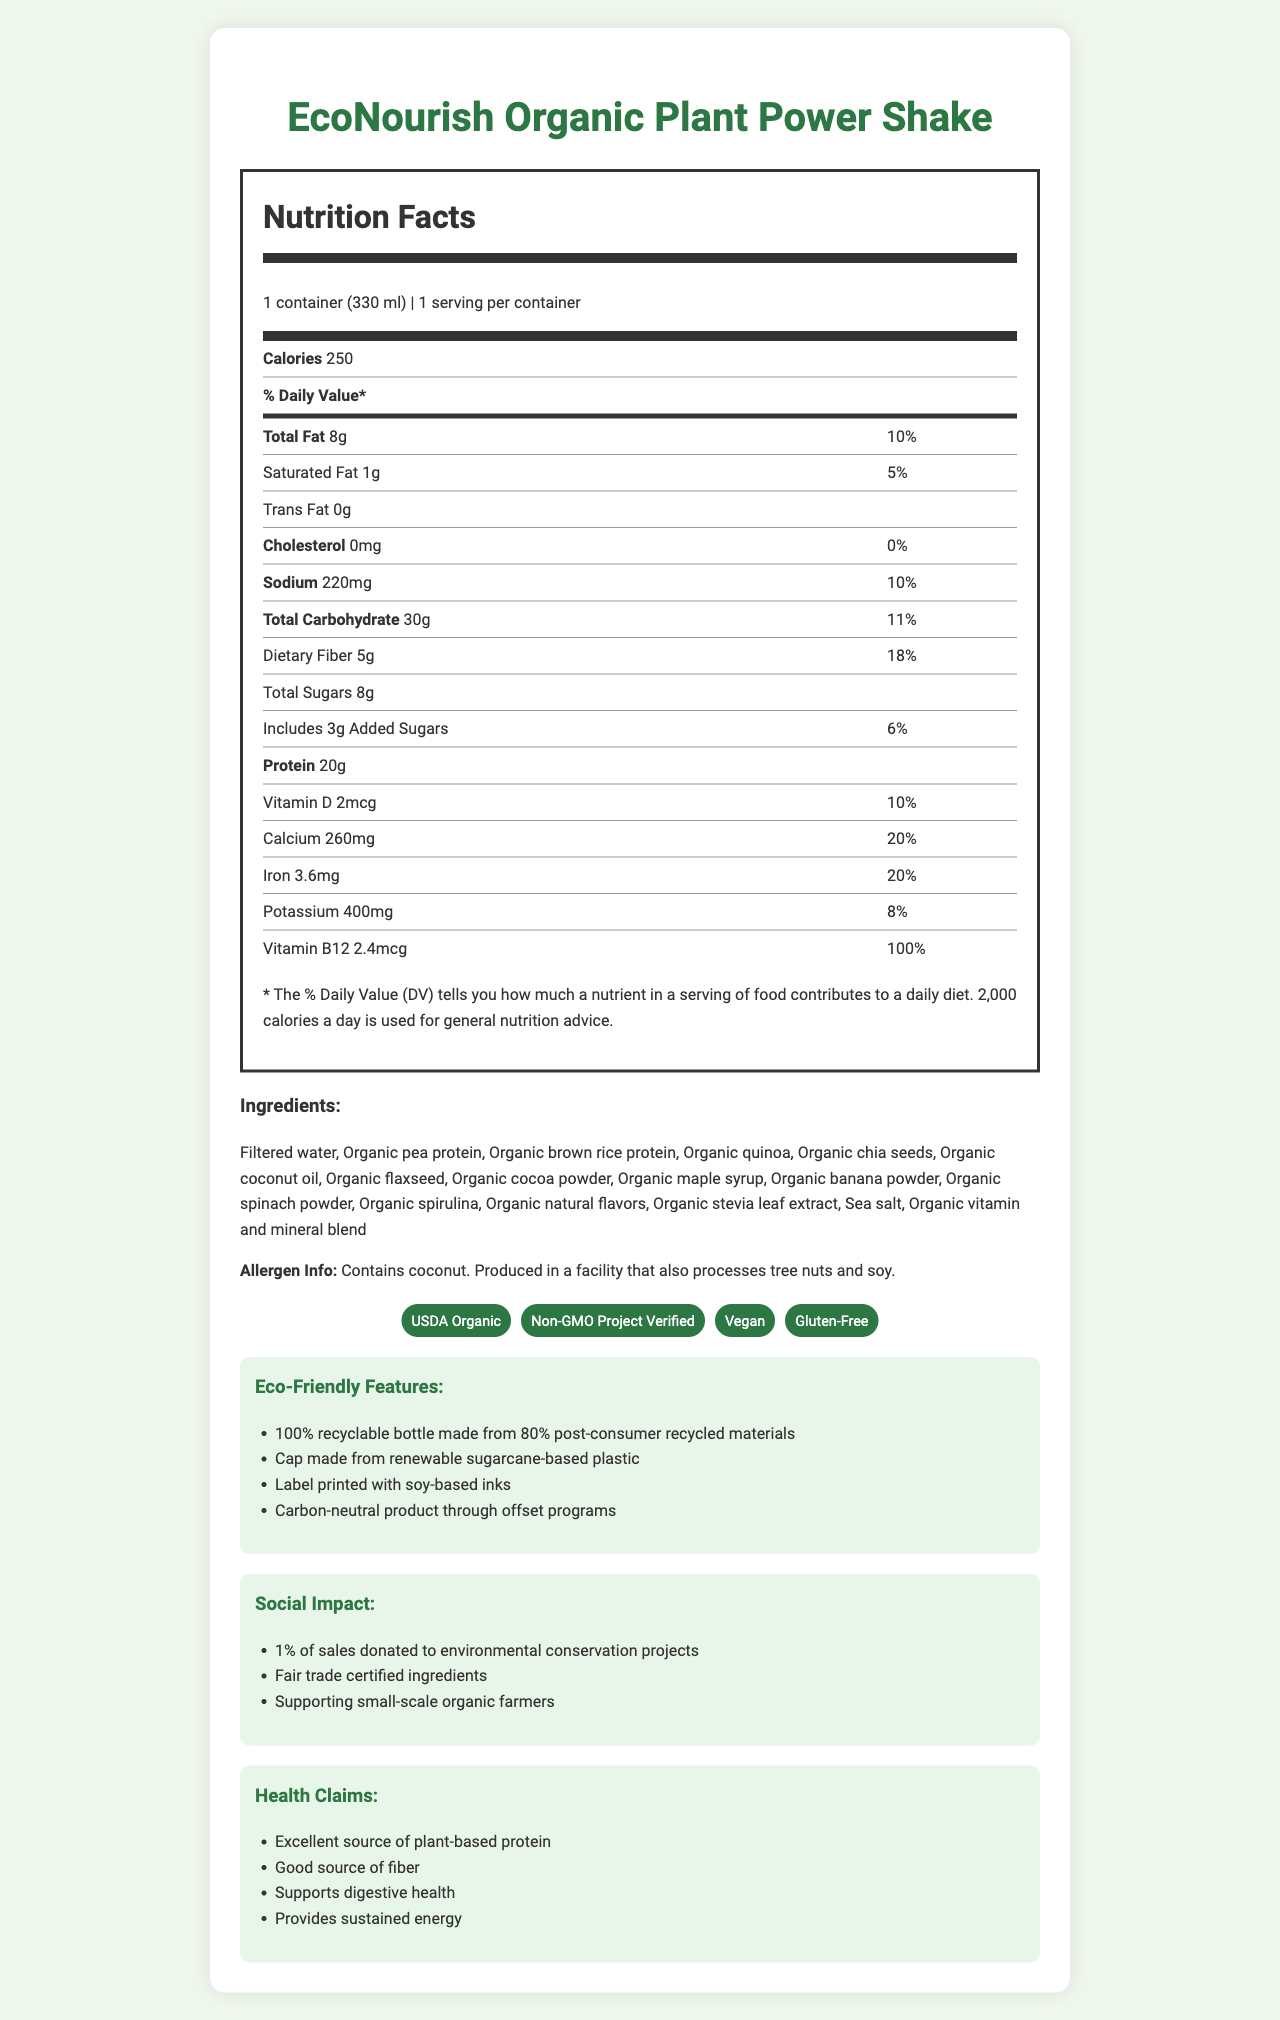what is the serving size of the EcoNourish Organic Plant Power Shake? The serving size is displayed at the top part of the Nutrition Facts section.
Answer: 1 container (330 ml) how many calories are in one serving? The number of calories is clearly stated in the Nutrition Facts section, under "Calories."
Answer: 250 what percentage of the daily value for dietary fiber does one serving provide? The daily value percentage for dietary fiber is listed next to its amount in the Total Carbohydrate section of the Nutrition Facts.
Answer: 18% what is the main protein source in the ingredients? Organic pea protein is explicitly listed as one of the ingredients.
Answer: Organic pea protein how much potassium is in the shake? The amount of potassium is listed towards the bottom of the Nutrition Facts table.
Answer: 400mg does the shake contain tree nuts other than coconut? The allergen info only indicates that it contains coconut and is produced in a facility that processes tree nuts, but it does not specify if there are other tree nuts in the product.
Answer: Cannot be determined which of the following certifications does the product have? A. Fair Trade Certified B. USDA Organic C. Certified Gluten-Free D. Non-GMO Project Verified The certifications mentioned for the product include USDA Organic and Non-GMO Project Verified.
Answer: B and D according to the document, which of these health claims are associated with the shake? I. Supports digestive health II. Provides Vitamin C III. Provides sustained energy IV. High in saturated fat The health claims listed in the document are "Supports digestive health" and "Provides sustained energy."
Answer: I and III is this product suitable for vegans? The document states the product is certified as Vegan.
Answer: Yes explain the eco-friendly features of EcoNourish Organic Plant Power Shake. The eco-friendly features are described in a dedicated section of the document, detailing the environmentally considerate design and manufacturing elements.
Answer: It includes a 100% recyclable bottle made from 80% post-consumer recycled materials, a cap made from renewable sugarcane-based plastic, label printed with soy-based inks, and it is a carbon-neutral product through offset programs. describe the social impact initiatives supported by this product. The social impact section of the document highlights these initiatives, indicating the company's commitment to social welfare and fair trade practices.
Answer: The product supports social impact initiatives including donating 1% of sales to environmental conservation projects, ensuring fair trade certified ingredients, and supporting small-scale organic farmers. 